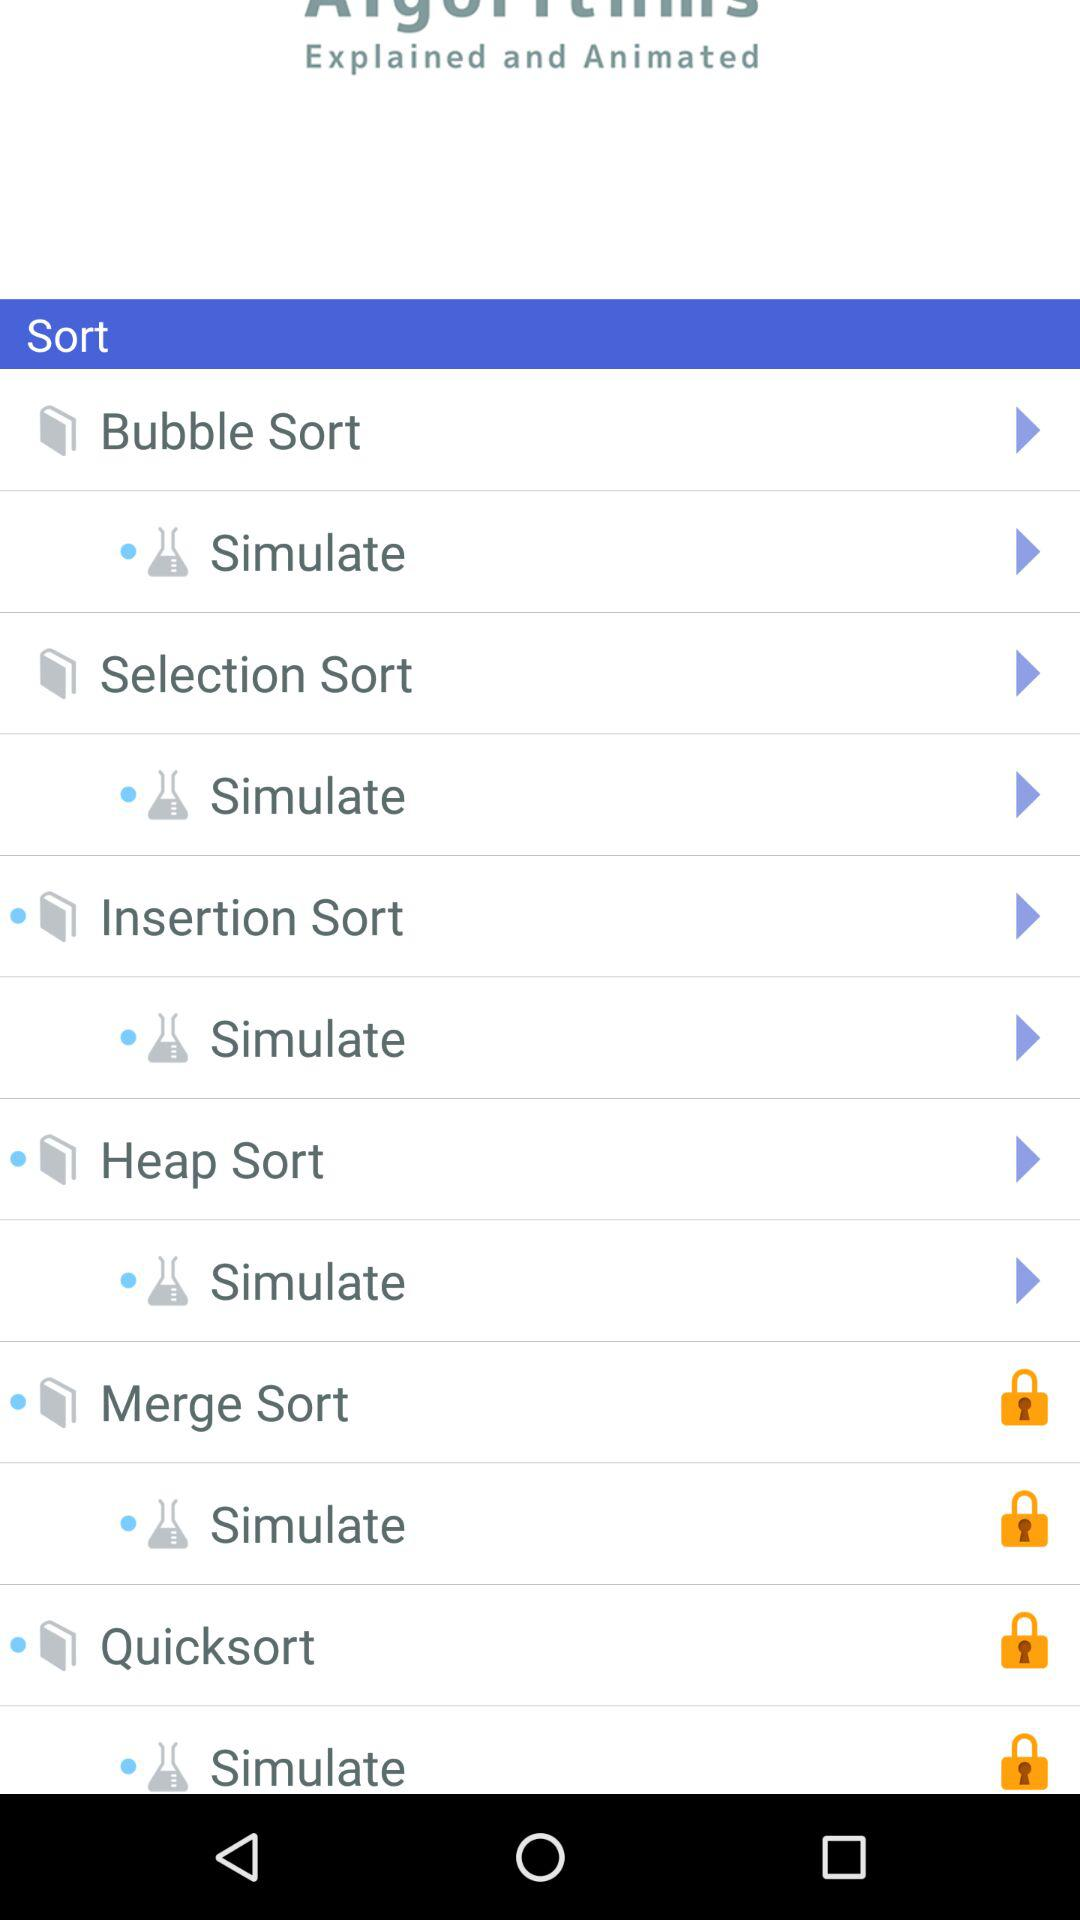How many sorting algorithms have an illustration of a beaker with blue liquid in it?
Answer the question using a single word or phrase. 4 